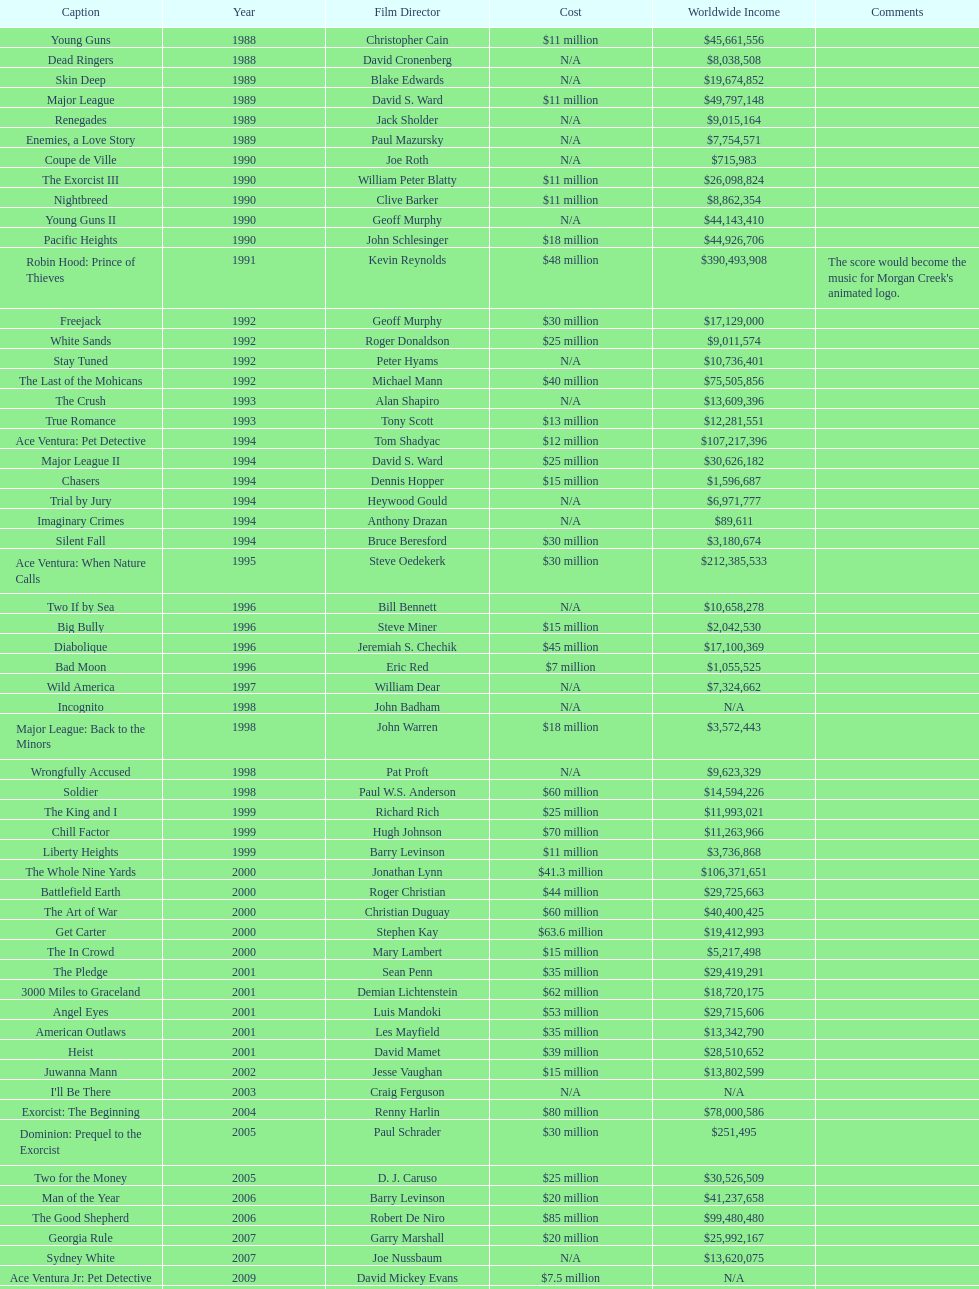Did true romance make more or less money than diabolique? Less. 